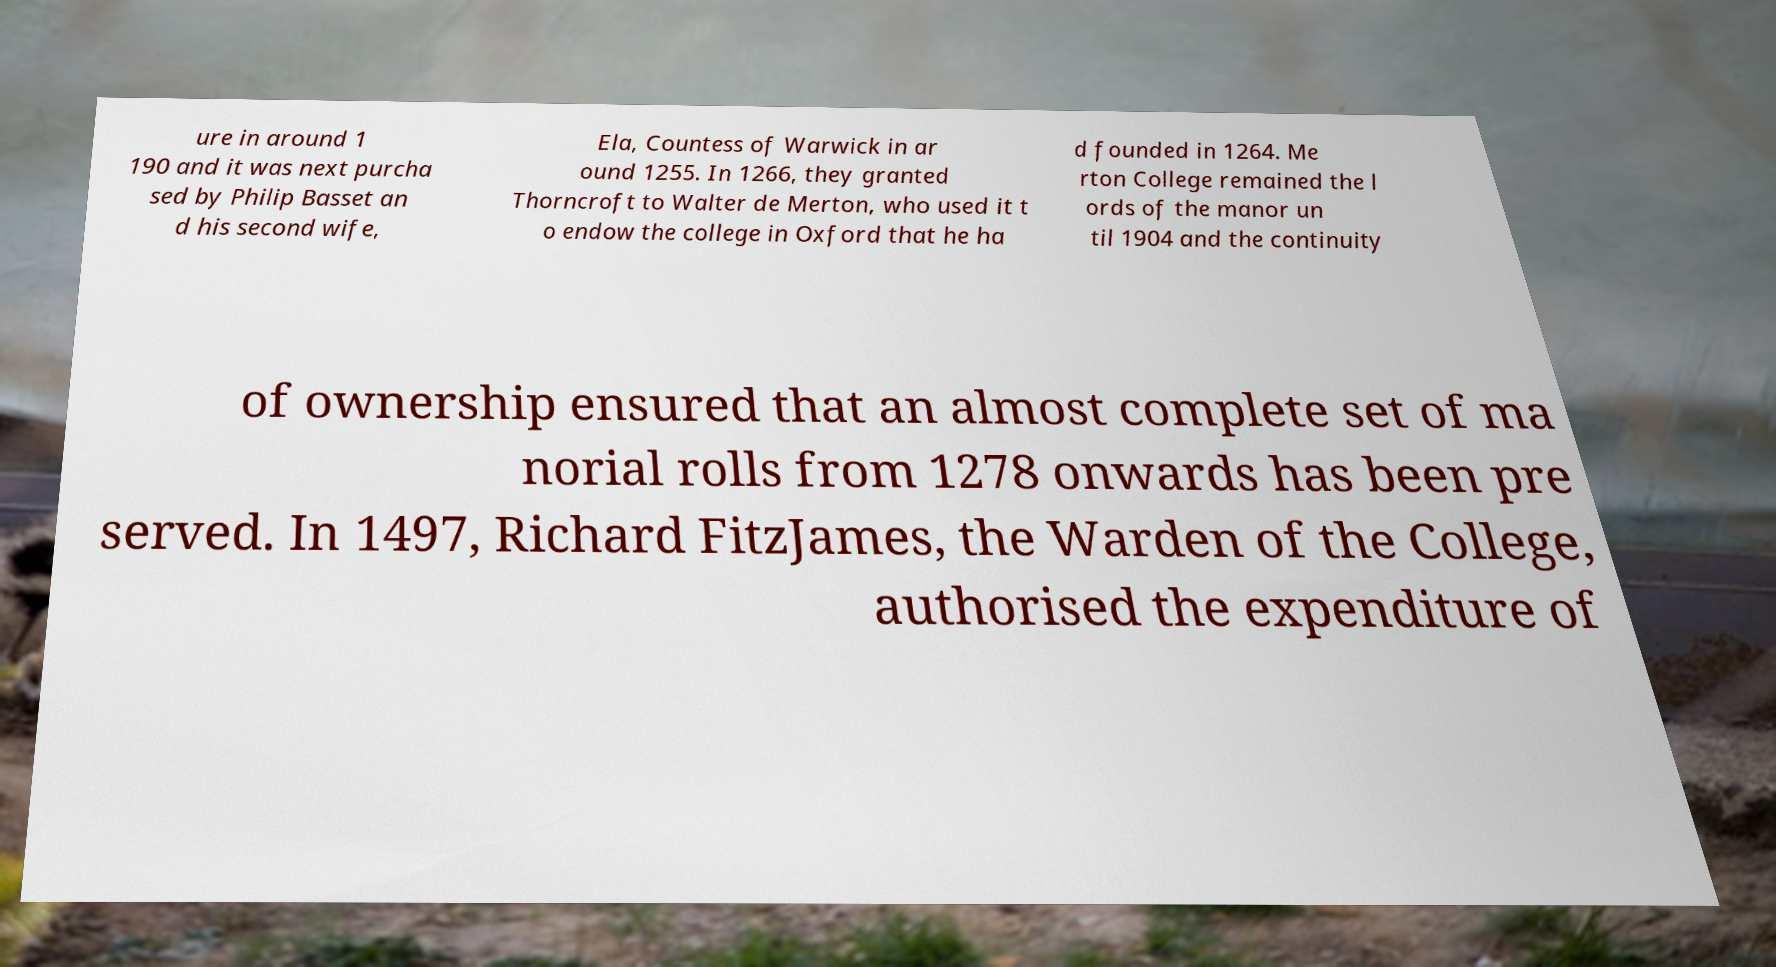Please read and relay the text visible in this image. What does it say? ure in around 1 190 and it was next purcha sed by Philip Basset an d his second wife, Ela, Countess of Warwick in ar ound 1255. In 1266, they granted Thorncroft to Walter de Merton, who used it t o endow the college in Oxford that he ha d founded in 1264. Me rton College remained the l ords of the manor un til 1904 and the continuity of ownership ensured that an almost complete set of ma norial rolls from 1278 onwards has been pre served. In 1497, Richard FitzJames, the Warden of the College, authorised the expenditure of 